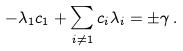Convert formula to latex. <formula><loc_0><loc_0><loc_500><loc_500>- \lambda _ { 1 } c _ { 1 } + \sum _ { i \neq 1 } c _ { i } \lambda _ { i } = \pm \gamma \, .</formula> 